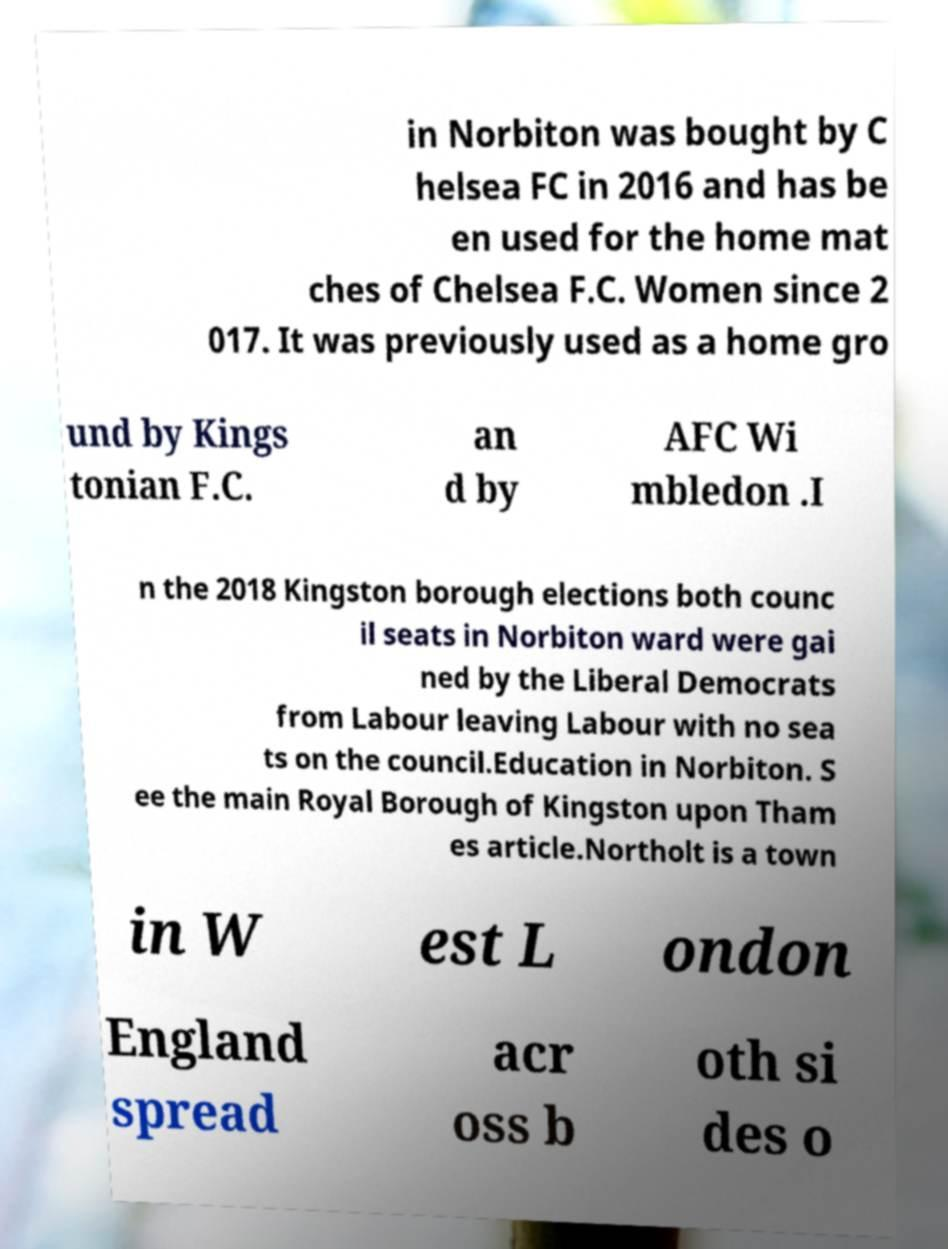There's text embedded in this image that I need extracted. Can you transcribe it verbatim? in Norbiton was bought by C helsea FC in 2016 and has be en used for the home mat ches of Chelsea F.C. Women since 2 017. It was previously used as a home gro und by Kings tonian F.C. an d by AFC Wi mbledon .I n the 2018 Kingston borough elections both counc il seats in Norbiton ward were gai ned by the Liberal Democrats from Labour leaving Labour with no sea ts on the council.Education in Norbiton. S ee the main Royal Borough of Kingston upon Tham es article.Northolt is a town in W est L ondon England spread acr oss b oth si des o 